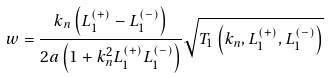<formula> <loc_0><loc_0><loc_500><loc_500>w = \frac { k _ { n } \left ( L _ { 1 } ^ { ( + ) } - L _ { 1 } ^ { ( - ) } \right ) } { 2 a \left ( 1 + k _ { n } ^ { 2 } L _ { 1 } ^ { ( + ) } L _ { 1 } ^ { ( - ) } \right ) } \sqrt { T _ { 1 } \left ( k _ { n } , L _ { 1 } ^ { ( + ) } , L _ { 1 } ^ { ( - ) } \right ) }</formula> 